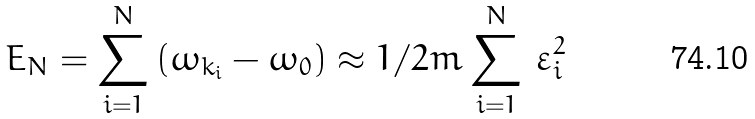<formula> <loc_0><loc_0><loc_500><loc_500>E _ { N } = \sum _ { i = 1 } ^ { N } \, ( \omega _ { k _ { i } } - \omega _ { 0 } ) \approx 1 / 2 m \sum _ { i = 1 } ^ { N } \, \varepsilon _ { i } ^ { 2 }</formula> 